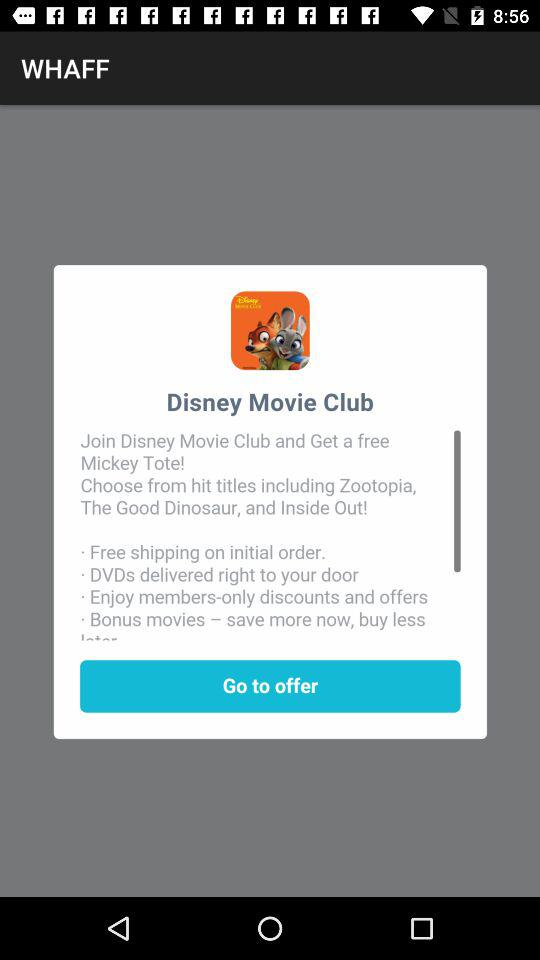What is the name of the club? The name of the club is "Disney Movie Club". 